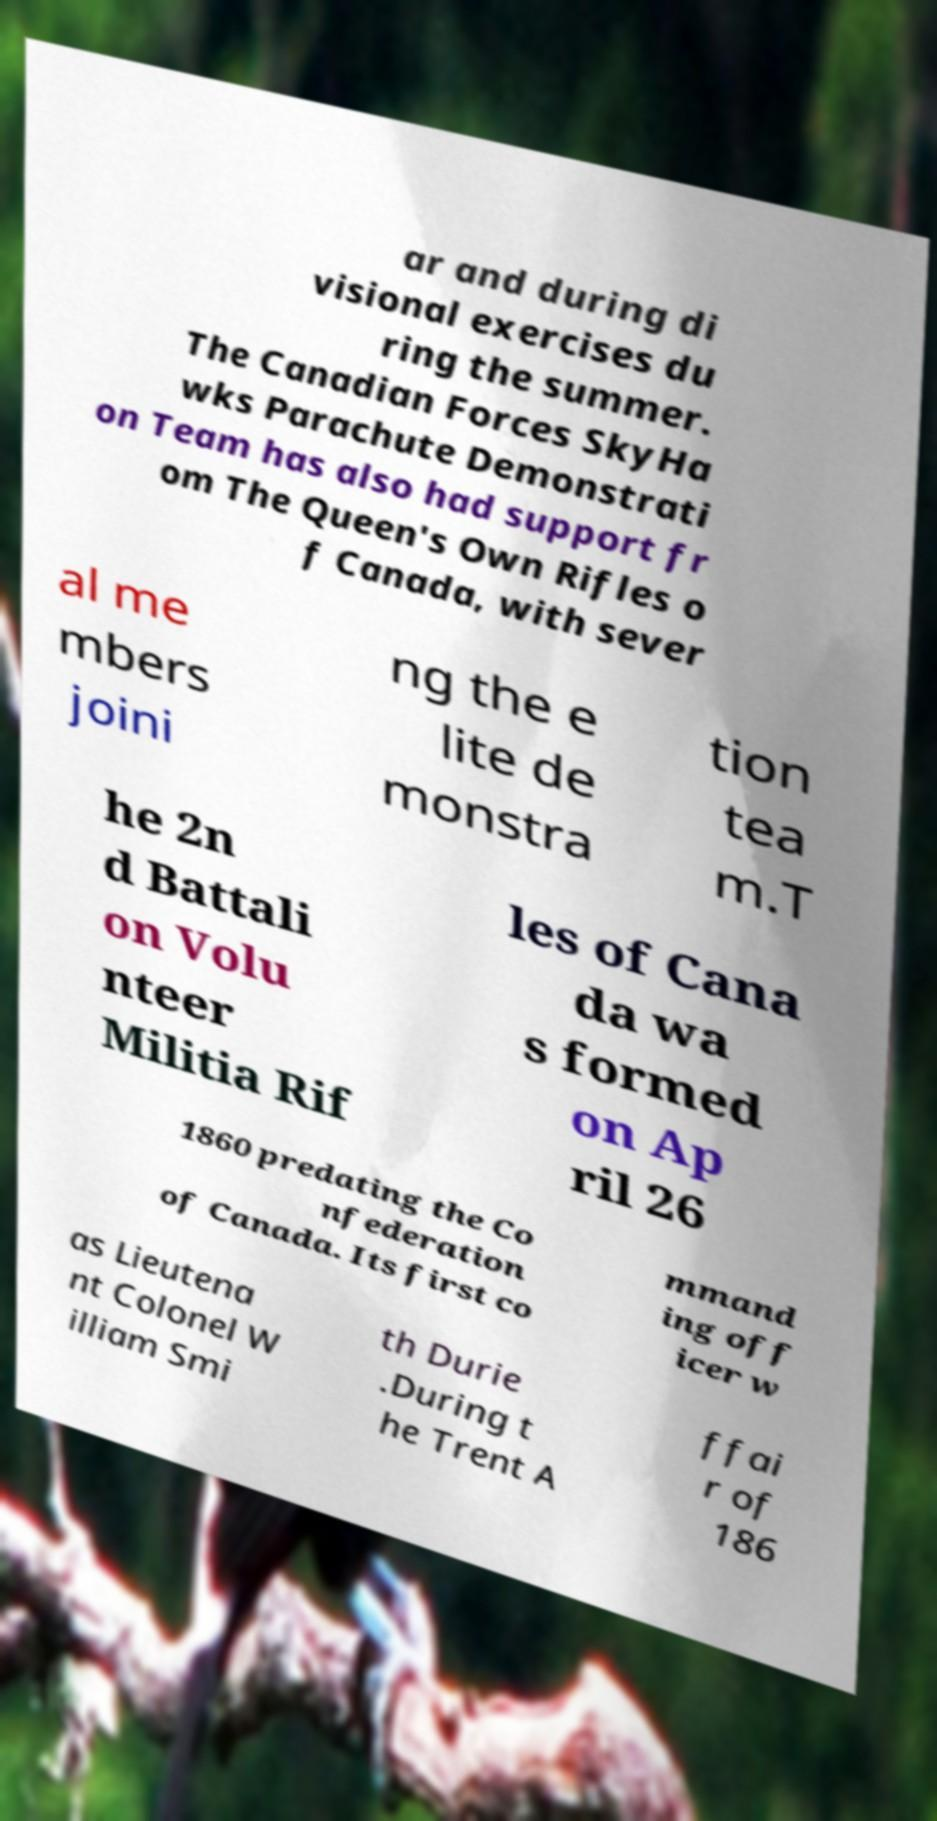Could you assist in decoding the text presented in this image and type it out clearly? ar and during di visional exercises du ring the summer. The Canadian Forces SkyHa wks Parachute Demonstrati on Team has also had support fr om The Queen's Own Rifles o f Canada, with sever al me mbers joini ng the e lite de monstra tion tea m.T he 2n d Battali on Volu nteer Militia Rif les of Cana da wa s formed on Ap ril 26 1860 predating the Co nfederation of Canada. Its first co mmand ing off icer w as Lieutena nt Colonel W illiam Smi th Durie .During t he Trent A ffai r of 186 